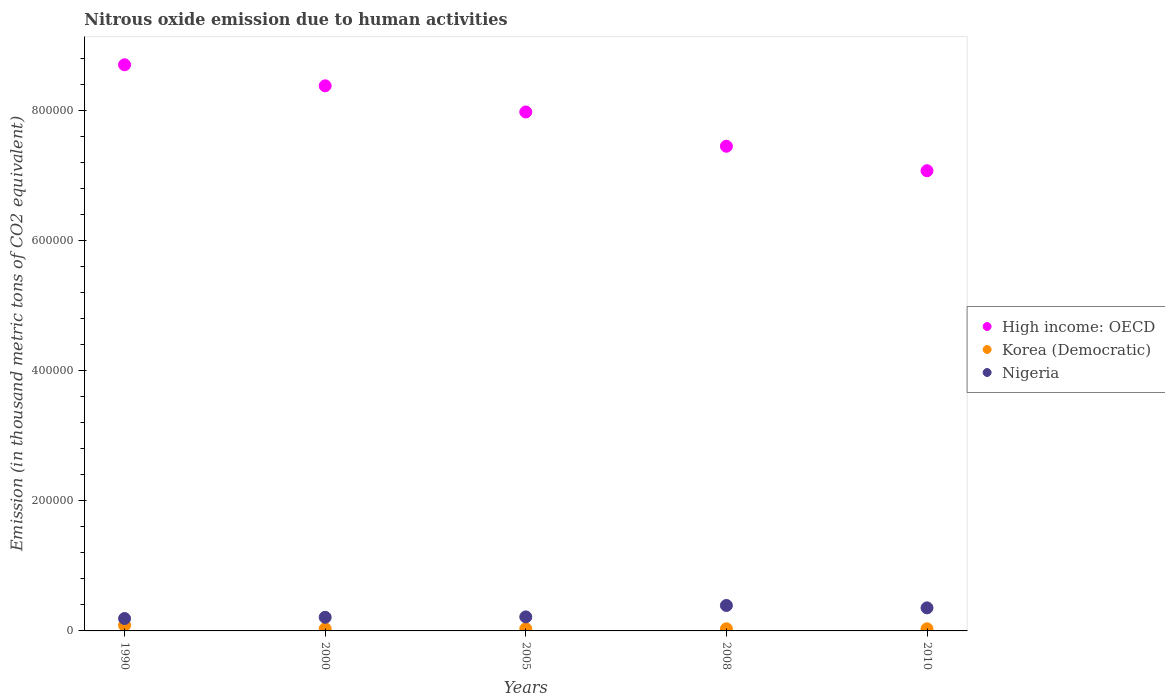Is the number of dotlines equal to the number of legend labels?
Make the answer very short. Yes. What is the amount of nitrous oxide emitted in Korea (Democratic) in 2000?
Provide a succinct answer. 3310.1. Across all years, what is the maximum amount of nitrous oxide emitted in High income: OECD?
Offer a very short reply. 8.71e+05. Across all years, what is the minimum amount of nitrous oxide emitted in Nigeria?
Offer a terse response. 1.90e+04. In which year was the amount of nitrous oxide emitted in Korea (Democratic) maximum?
Keep it short and to the point. 1990. In which year was the amount of nitrous oxide emitted in Korea (Democratic) minimum?
Provide a succinct answer. 2010. What is the total amount of nitrous oxide emitted in Nigeria in the graph?
Offer a very short reply. 1.36e+05. What is the difference between the amount of nitrous oxide emitted in Korea (Democratic) in 2008 and that in 2010?
Provide a succinct answer. 35.7. What is the difference between the amount of nitrous oxide emitted in Korea (Democratic) in 2005 and the amount of nitrous oxide emitted in High income: OECD in 2010?
Provide a short and direct response. -7.05e+05. What is the average amount of nitrous oxide emitted in Korea (Democratic) per year?
Your response must be concise. 4381.74. In the year 2000, what is the difference between the amount of nitrous oxide emitted in Korea (Democratic) and amount of nitrous oxide emitted in Nigeria?
Give a very brief answer. -1.77e+04. In how many years, is the amount of nitrous oxide emitted in Korea (Democratic) greater than 680000 thousand metric tons?
Your response must be concise. 0. What is the ratio of the amount of nitrous oxide emitted in High income: OECD in 2000 to that in 2005?
Your answer should be very brief. 1.05. Is the amount of nitrous oxide emitted in Korea (Democratic) in 2000 less than that in 2008?
Your answer should be very brief. No. What is the difference between the highest and the second highest amount of nitrous oxide emitted in Nigeria?
Give a very brief answer. 3687.6. What is the difference between the highest and the lowest amount of nitrous oxide emitted in High income: OECD?
Give a very brief answer. 1.63e+05. In how many years, is the amount of nitrous oxide emitted in Nigeria greater than the average amount of nitrous oxide emitted in Nigeria taken over all years?
Make the answer very short. 2. Is the amount of nitrous oxide emitted in Korea (Democratic) strictly greater than the amount of nitrous oxide emitted in Nigeria over the years?
Your answer should be compact. No. How many years are there in the graph?
Your answer should be compact. 5. What is the difference between two consecutive major ticks on the Y-axis?
Keep it short and to the point. 2.00e+05. Are the values on the major ticks of Y-axis written in scientific E-notation?
Offer a very short reply. No. Where does the legend appear in the graph?
Ensure brevity in your answer.  Center right. How many legend labels are there?
Offer a very short reply. 3. How are the legend labels stacked?
Provide a short and direct response. Vertical. What is the title of the graph?
Make the answer very short. Nitrous oxide emission due to human activities. What is the label or title of the Y-axis?
Your response must be concise. Emission (in thousand metric tons of CO2 equivalent). What is the Emission (in thousand metric tons of CO2 equivalent) in High income: OECD in 1990?
Provide a short and direct response. 8.71e+05. What is the Emission (in thousand metric tons of CO2 equivalent) of Korea (Democratic) in 1990?
Offer a very short reply. 8714.8. What is the Emission (in thousand metric tons of CO2 equivalent) in Nigeria in 1990?
Provide a succinct answer. 1.90e+04. What is the Emission (in thousand metric tons of CO2 equivalent) in High income: OECD in 2000?
Your response must be concise. 8.39e+05. What is the Emission (in thousand metric tons of CO2 equivalent) of Korea (Democratic) in 2000?
Offer a terse response. 3310.1. What is the Emission (in thousand metric tons of CO2 equivalent) of Nigeria in 2000?
Give a very brief answer. 2.10e+04. What is the Emission (in thousand metric tons of CO2 equivalent) in High income: OECD in 2005?
Offer a very short reply. 7.98e+05. What is the Emission (in thousand metric tons of CO2 equivalent) of Korea (Democratic) in 2005?
Give a very brief answer. 3365.7. What is the Emission (in thousand metric tons of CO2 equivalent) of Nigeria in 2005?
Make the answer very short. 2.16e+04. What is the Emission (in thousand metric tons of CO2 equivalent) of High income: OECD in 2008?
Keep it short and to the point. 7.46e+05. What is the Emission (in thousand metric tons of CO2 equivalent) in Korea (Democratic) in 2008?
Keep it short and to the point. 3276.9. What is the Emission (in thousand metric tons of CO2 equivalent) of Nigeria in 2008?
Provide a succinct answer. 3.92e+04. What is the Emission (in thousand metric tons of CO2 equivalent) of High income: OECD in 2010?
Ensure brevity in your answer.  7.08e+05. What is the Emission (in thousand metric tons of CO2 equivalent) in Korea (Democratic) in 2010?
Your answer should be compact. 3241.2. What is the Emission (in thousand metric tons of CO2 equivalent) in Nigeria in 2010?
Offer a terse response. 3.55e+04. Across all years, what is the maximum Emission (in thousand metric tons of CO2 equivalent) in High income: OECD?
Your answer should be very brief. 8.71e+05. Across all years, what is the maximum Emission (in thousand metric tons of CO2 equivalent) of Korea (Democratic)?
Provide a succinct answer. 8714.8. Across all years, what is the maximum Emission (in thousand metric tons of CO2 equivalent) in Nigeria?
Your answer should be very brief. 3.92e+04. Across all years, what is the minimum Emission (in thousand metric tons of CO2 equivalent) of High income: OECD?
Keep it short and to the point. 7.08e+05. Across all years, what is the minimum Emission (in thousand metric tons of CO2 equivalent) in Korea (Democratic)?
Give a very brief answer. 3241.2. Across all years, what is the minimum Emission (in thousand metric tons of CO2 equivalent) in Nigeria?
Make the answer very short. 1.90e+04. What is the total Emission (in thousand metric tons of CO2 equivalent) of High income: OECD in the graph?
Provide a short and direct response. 3.96e+06. What is the total Emission (in thousand metric tons of CO2 equivalent) in Korea (Democratic) in the graph?
Make the answer very short. 2.19e+04. What is the total Emission (in thousand metric tons of CO2 equivalent) of Nigeria in the graph?
Give a very brief answer. 1.36e+05. What is the difference between the Emission (in thousand metric tons of CO2 equivalent) of High income: OECD in 1990 and that in 2000?
Your answer should be compact. 3.24e+04. What is the difference between the Emission (in thousand metric tons of CO2 equivalent) in Korea (Democratic) in 1990 and that in 2000?
Offer a very short reply. 5404.7. What is the difference between the Emission (in thousand metric tons of CO2 equivalent) of Nigeria in 1990 and that in 2000?
Provide a succinct answer. -1924. What is the difference between the Emission (in thousand metric tons of CO2 equivalent) of High income: OECD in 1990 and that in 2005?
Offer a terse response. 7.26e+04. What is the difference between the Emission (in thousand metric tons of CO2 equivalent) of Korea (Democratic) in 1990 and that in 2005?
Ensure brevity in your answer.  5349.1. What is the difference between the Emission (in thousand metric tons of CO2 equivalent) in Nigeria in 1990 and that in 2005?
Keep it short and to the point. -2524.4. What is the difference between the Emission (in thousand metric tons of CO2 equivalent) of High income: OECD in 1990 and that in 2008?
Your answer should be compact. 1.25e+05. What is the difference between the Emission (in thousand metric tons of CO2 equivalent) in Korea (Democratic) in 1990 and that in 2008?
Your answer should be very brief. 5437.9. What is the difference between the Emission (in thousand metric tons of CO2 equivalent) in Nigeria in 1990 and that in 2008?
Offer a very short reply. -2.01e+04. What is the difference between the Emission (in thousand metric tons of CO2 equivalent) of High income: OECD in 1990 and that in 2010?
Your answer should be very brief. 1.63e+05. What is the difference between the Emission (in thousand metric tons of CO2 equivalent) in Korea (Democratic) in 1990 and that in 2010?
Your answer should be very brief. 5473.6. What is the difference between the Emission (in thousand metric tons of CO2 equivalent) in Nigeria in 1990 and that in 2010?
Offer a terse response. -1.64e+04. What is the difference between the Emission (in thousand metric tons of CO2 equivalent) of High income: OECD in 2000 and that in 2005?
Your answer should be very brief. 4.02e+04. What is the difference between the Emission (in thousand metric tons of CO2 equivalent) of Korea (Democratic) in 2000 and that in 2005?
Provide a succinct answer. -55.6. What is the difference between the Emission (in thousand metric tons of CO2 equivalent) in Nigeria in 2000 and that in 2005?
Provide a short and direct response. -600.4. What is the difference between the Emission (in thousand metric tons of CO2 equivalent) of High income: OECD in 2000 and that in 2008?
Make the answer very short. 9.30e+04. What is the difference between the Emission (in thousand metric tons of CO2 equivalent) of Korea (Democratic) in 2000 and that in 2008?
Offer a terse response. 33.2. What is the difference between the Emission (in thousand metric tons of CO2 equivalent) of Nigeria in 2000 and that in 2008?
Your answer should be compact. -1.82e+04. What is the difference between the Emission (in thousand metric tons of CO2 equivalent) of High income: OECD in 2000 and that in 2010?
Make the answer very short. 1.31e+05. What is the difference between the Emission (in thousand metric tons of CO2 equivalent) of Korea (Democratic) in 2000 and that in 2010?
Provide a short and direct response. 68.9. What is the difference between the Emission (in thousand metric tons of CO2 equivalent) of Nigeria in 2000 and that in 2010?
Make the answer very short. -1.45e+04. What is the difference between the Emission (in thousand metric tons of CO2 equivalent) in High income: OECD in 2005 and that in 2008?
Offer a very short reply. 5.27e+04. What is the difference between the Emission (in thousand metric tons of CO2 equivalent) of Korea (Democratic) in 2005 and that in 2008?
Offer a terse response. 88.8. What is the difference between the Emission (in thousand metric tons of CO2 equivalent) in Nigeria in 2005 and that in 2008?
Offer a terse response. -1.76e+04. What is the difference between the Emission (in thousand metric tons of CO2 equivalent) of High income: OECD in 2005 and that in 2010?
Provide a succinct answer. 9.04e+04. What is the difference between the Emission (in thousand metric tons of CO2 equivalent) in Korea (Democratic) in 2005 and that in 2010?
Provide a succinct answer. 124.5. What is the difference between the Emission (in thousand metric tons of CO2 equivalent) in Nigeria in 2005 and that in 2010?
Keep it short and to the point. -1.39e+04. What is the difference between the Emission (in thousand metric tons of CO2 equivalent) in High income: OECD in 2008 and that in 2010?
Keep it short and to the point. 3.77e+04. What is the difference between the Emission (in thousand metric tons of CO2 equivalent) in Korea (Democratic) in 2008 and that in 2010?
Ensure brevity in your answer.  35.7. What is the difference between the Emission (in thousand metric tons of CO2 equivalent) of Nigeria in 2008 and that in 2010?
Offer a very short reply. 3687.6. What is the difference between the Emission (in thousand metric tons of CO2 equivalent) of High income: OECD in 1990 and the Emission (in thousand metric tons of CO2 equivalent) of Korea (Democratic) in 2000?
Ensure brevity in your answer.  8.68e+05. What is the difference between the Emission (in thousand metric tons of CO2 equivalent) in High income: OECD in 1990 and the Emission (in thousand metric tons of CO2 equivalent) in Nigeria in 2000?
Your answer should be compact. 8.50e+05. What is the difference between the Emission (in thousand metric tons of CO2 equivalent) in Korea (Democratic) in 1990 and the Emission (in thousand metric tons of CO2 equivalent) in Nigeria in 2000?
Ensure brevity in your answer.  -1.23e+04. What is the difference between the Emission (in thousand metric tons of CO2 equivalent) in High income: OECD in 1990 and the Emission (in thousand metric tons of CO2 equivalent) in Korea (Democratic) in 2005?
Your response must be concise. 8.68e+05. What is the difference between the Emission (in thousand metric tons of CO2 equivalent) in High income: OECD in 1990 and the Emission (in thousand metric tons of CO2 equivalent) in Nigeria in 2005?
Ensure brevity in your answer.  8.49e+05. What is the difference between the Emission (in thousand metric tons of CO2 equivalent) in Korea (Democratic) in 1990 and the Emission (in thousand metric tons of CO2 equivalent) in Nigeria in 2005?
Make the answer very short. -1.29e+04. What is the difference between the Emission (in thousand metric tons of CO2 equivalent) in High income: OECD in 1990 and the Emission (in thousand metric tons of CO2 equivalent) in Korea (Democratic) in 2008?
Give a very brief answer. 8.68e+05. What is the difference between the Emission (in thousand metric tons of CO2 equivalent) of High income: OECD in 1990 and the Emission (in thousand metric tons of CO2 equivalent) of Nigeria in 2008?
Provide a short and direct response. 8.32e+05. What is the difference between the Emission (in thousand metric tons of CO2 equivalent) of Korea (Democratic) in 1990 and the Emission (in thousand metric tons of CO2 equivalent) of Nigeria in 2008?
Make the answer very short. -3.04e+04. What is the difference between the Emission (in thousand metric tons of CO2 equivalent) of High income: OECD in 1990 and the Emission (in thousand metric tons of CO2 equivalent) of Korea (Democratic) in 2010?
Your answer should be very brief. 8.68e+05. What is the difference between the Emission (in thousand metric tons of CO2 equivalent) of High income: OECD in 1990 and the Emission (in thousand metric tons of CO2 equivalent) of Nigeria in 2010?
Your answer should be very brief. 8.36e+05. What is the difference between the Emission (in thousand metric tons of CO2 equivalent) in Korea (Democratic) in 1990 and the Emission (in thousand metric tons of CO2 equivalent) in Nigeria in 2010?
Ensure brevity in your answer.  -2.68e+04. What is the difference between the Emission (in thousand metric tons of CO2 equivalent) of High income: OECD in 2000 and the Emission (in thousand metric tons of CO2 equivalent) of Korea (Democratic) in 2005?
Provide a succinct answer. 8.35e+05. What is the difference between the Emission (in thousand metric tons of CO2 equivalent) of High income: OECD in 2000 and the Emission (in thousand metric tons of CO2 equivalent) of Nigeria in 2005?
Ensure brevity in your answer.  8.17e+05. What is the difference between the Emission (in thousand metric tons of CO2 equivalent) of Korea (Democratic) in 2000 and the Emission (in thousand metric tons of CO2 equivalent) of Nigeria in 2005?
Your answer should be very brief. -1.83e+04. What is the difference between the Emission (in thousand metric tons of CO2 equivalent) in High income: OECD in 2000 and the Emission (in thousand metric tons of CO2 equivalent) in Korea (Democratic) in 2008?
Offer a very short reply. 8.35e+05. What is the difference between the Emission (in thousand metric tons of CO2 equivalent) of High income: OECD in 2000 and the Emission (in thousand metric tons of CO2 equivalent) of Nigeria in 2008?
Your answer should be very brief. 7.99e+05. What is the difference between the Emission (in thousand metric tons of CO2 equivalent) of Korea (Democratic) in 2000 and the Emission (in thousand metric tons of CO2 equivalent) of Nigeria in 2008?
Your response must be concise. -3.59e+04. What is the difference between the Emission (in thousand metric tons of CO2 equivalent) of High income: OECD in 2000 and the Emission (in thousand metric tons of CO2 equivalent) of Korea (Democratic) in 2010?
Keep it short and to the point. 8.35e+05. What is the difference between the Emission (in thousand metric tons of CO2 equivalent) in High income: OECD in 2000 and the Emission (in thousand metric tons of CO2 equivalent) in Nigeria in 2010?
Offer a terse response. 8.03e+05. What is the difference between the Emission (in thousand metric tons of CO2 equivalent) in Korea (Democratic) in 2000 and the Emission (in thousand metric tons of CO2 equivalent) in Nigeria in 2010?
Provide a short and direct response. -3.22e+04. What is the difference between the Emission (in thousand metric tons of CO2 equivalent) in High income: OECD in 2005 and the Emission (in thousand metric tons of CO2 equivalent) in Korea (Democratic) in 2008?
Keep it short and to the point. 7.95e+05. What is the difference between the Emission (in thousand metric tons of CO2 equivalent) of High income: OECD in 2005 and the Emission (in thousand metric tons of CO2 equivalent) of Nigeria in 2008?
Make the answer very short. 7.59e+05. What is the difference between the Emission (in thousand metric tons of CO2 equivalent) in Korea (Democratic) in 2005 and the Emission (in thousand metric tons of CO2 equivalent) in Nigeria in 2008?
Give a very brief answer. -3.58e+04. What is the difference between the Emission (in thousand metric tons of CO2 equivalent) in High income: OECD in 2005 and the Emission (in thousand metric tons of CO2 equivalent) in Korea (Democratic) in 2010?
Make the answer very short. 7.95e+05. What is the difference between the Emission (in thousand metric tons of CO2 equivalent) in High income: OECD in 2005 and the Emission (in thousand metric tons of CO2 equivalent) in Nigeria in 2010?
Make the answer very short. 7.63e+05. What is the difference between the Emission (in thousand metric tons of CO2 equivalent) of Korea (Democratic) in 2005 and the Emission (in thousand metric tons of CO2 equivalent) of Nigeria in 2010?
Your answer should be very brief. -3.21e+04. What is the difference between the Emission (in thousand metric tons of CO2 equivalent) of High income: OECD in 2008 and the Emission (in thousand metric tons of CO2 equivalent) of Korea (Democratic) in 2010?
Your response must be concise. 7.42e+05. What is the difference between the Emission (in thousand metric tons of CO2 equivalent) of High income: OECD in 2008 and the Emission (in thousand metric tons of CO2 equivalent) of Nigeria in 2010?
Ensure brevity in your answer.  7.10e+05. What is the difference between the Emission (in thousand metric tons of CO2 equivalent) in Korea (Democratic) in 2008 and the Emission (in thousand metric tons of CO2 equivalent) in Nigeria in 2010?
Your response must be concise. -3.22e+04. What is the average Emission (in thousand metric tons of CO2 equivalent) of High income: OECD per year?
Provide a succinct answer. 7.92e+05. What is the average Emission (in thousand metric tons of CO2 equivalent) of Korea (Democratic) per year?
Your response must be concise. 4381.74. What is the average Emission (in thousand metric tons of CO2 equivalent) of Nigeria per year?
Your response must be concise. 2.72e+04. In the year 1990, what is the difference between the Emission (in thousand metric tons of CO2 equivalent) in High income: OECD and Emission (in thousand metric tons of CO2 equivalent) in Korea (Democratic)?
Ensure brevity in your answer.  8.62e+05. In the year 1990, what is the difference between the Emission (in thousand metric tons of CO2 equivalent) in High income: OECD and Emission (in thousand metric tons of CO2 equivalent) in Nigeria?
Provide a short and direct response. 8.52e+05. In the year 1990, what is the difference between the Emission (in thousand metric tons of CO2 equivalent) of Korea (Democratic) and Emission (in thousand metric tons of CO2 equivalent) of Nigeria?
Keep it short and to the point. -1.03e+04. In the year 2000, what is the difference between the Emission (in thousand metric tons of CO2 equivalent) in High income: OECD and Emission (in thousand metric tons of CO2 equivalent) in Korea (Democratic)?
Your answer should be compact. 8.35e+05. In the year 2000, what is the difference between the Emission (in thousand metric tons of CO2 equivalent) of High income: OECD and Emission (in thousand metric tons of CO2 equivalent) of Nigeria?
Provide a short and direct response. 8.18e+05. In the year 2000, what is the difference between the Emission (in thousand metric tons of CO2 equivalent) of Korea (Democratic) and Emission (in thousand metric tons of CO2 equivalent) of Nigeria?
Make the answer very short. -1.77e+04. In the year 2005, what is the difference between the Emission (in thousand metric tons of CO2 equivalent) in High income: OECD and Emission (in thousand metric tons of CO2 equivalent) in Korea (Democratic)?
Provide a succinct answer. 7.95e+05. In the year 2005, what is the difference between the Emission (in thousand metric tons of CO2 equivalent) in High income: OECD and Emission (in thousand metric tons of CO2 equivalent) in Nigeria?
Provide a succinct answer. 7.77e+05. In the year 2005, what is the difference between the Emission (in thousand metric tons of CO2 equivalent) in Korea (Democratic) and Emission (in thousand metric tons of CO2 equivalent) in Nigeria?
Your response must be concise. -1.82e+04. In the year 2008, what is the difference between the Emission (in thousand metric tons of CO2 equivalent) of High income: OECD and Emission (in thousand metric tons of CO2 equivalent) of Korea (Democratic)?
Provide a succinct answer. 7.42e+05. In the year 2008, what is the difference between the Emission (in thousand metric tons of CO2 equivalent) in High income: OECD and Emission (in thousand metric tons of CO2 equivalent) in Nigeria?
Your answer should be very brief. 7.07e+05. In the year 2008, what is the difference between the Emission (in thousand metric tons of CO2 equivalent) in Korea (Democratic) and Emission (in thousand metric tons of CO2 equivalent) in Nigeria?
Your response must be concise. -3.59e+04. In the year 2010, what is the difference between the Emission (in thousand metric tons of CO2 equivalent) of High income: OECD and Emission (in thousand metric tons of CO2 equivalent) of Korea (Democratic)?
Ensure brevity in your answer.  7.05e+05. In the year 2010, what is the difference between the Emission (in thousand metric tons of CO2 equivalent) in High income: OECD and Emission (in thousand metric tons of CO2 equivalent) in Nigeria?
Give a very brief answer. 6.73e+05. In the year 2010, what is the difference between the Emission (in thousand metric tons of CO2 equivalent) of Korea (Democratic) and Emission (in thousand metric tons of CO2 equivalent) of Nigeria?
Provide a short and direct response. -3.22e+04. What is the ratio of the Emission (in thousand metric tons of CO2 equivalent) in High income: OECD in 1990 to that in 2000?
Your answer should be very brief. 1.04. What is the ratio of the Emission (in thousand metric tons of CO2 equivalent) in Korea (Democratic) in 1990 to that in 2000?
Offer a terse response. 2.63. What is the ratio of the Emission (in thousand metric tons of CO2 equivalent) of Nigeria in 1990 to that in 2000?
Make the answer very short. 0.91. What is the ratio of the Emission (in thousand metric tons of CO2 equivalent) of Korea (Democratic) in 1990 to that in 2005?
Keep it short and to the point. 2.59. What is the ratio of the Emission (in thousand metric tons of CO2 equivalent) of Nigeria in 1990 to that in 2005?
Offer a very short reply. 0.88. What is the ratio of the Emission (in thousand metric tons of CO2 equivalent) of High income: OECD in 1990 to that in 2008?
Provide a short and direct response. 1.17. What is the ratio of the Emission (in thousand metric tons of CO2 equivalent) of Korea (Democratic) in 1990 to that in 2008?
Make the answer very short. 2.66. What is the ratio of the Emission (in thousand metric tons of CO2 equivalent) of Nigeria in 1990 to that in 2008?
Your response must be concise. 0.49. What is the ratio of the Emission (in thousand metric tons of CO2 equivalent) of High income: OECD in 1990 to that in 2010?
Your answer should be very brief. 1.23. What is the ratio of the Emission (in thousand metric tons of CO2 equivalent) of Korea (Democratic) in 1990 to that in 2010?
Make the answer very short. 2.69. What is the ratio of the Emission (in thousand metric tons of CO2 equivalent) of Nigeria in 1990 to that in 2010?
Offer a very short reply. 0.54. What is the ratio of the Emission (in thousand metric tons of CO2 equivalent) in High income: OECD in 2000 to that in 2005?
Offer a terse response. 1.05. What is the ratio of the Emission (in thousand metric tons of CO2 equivalent) in Korea (Democratic) in 2000 to that in 2005?
Make the answer very short. 0.98. What is the ratio of the Emission (in thousand metric tons of CO2 equivalent) in Nigeria in 2000 to that in 2005?
Offer a very short reply. 0.97. What is the ratio of the Emission (in thousand metric tons of CO2 equivalent) in High income: OECD in 2000 to that in 2008?
Ensure brevity in your answer.  1.12. What is the ratio of the Emission (in thousand metric tons of CO2 equivalent) of Nigeria in 2000 to that in 2008?
Ensure brevity in your answer.  0.54. What is the ratio of the Emission (in thousand metric tons of CO2 equivalent) of High income: OECD in 2000 to that in 2010?
Offer a terse response. 1.18. What is the ratio of the Emission (in thousand metric tons of CO2 equivalent) of Korea (Democratic) in 2000 to that in 2010?
Give a very brief answer. 1.02. What is the ratio of the Emission (in thousand metric tons of CO2 equivalent) in Nigeria in 2000 to that in 2010?
Your answer should be compact. 0.59. What is the ratio of the Emission (in thousand metric tons of CO2 equivalent) of High income: OECD in 2005 to that in 2008?
Offer a terse response. 1.07. What is the ratio of the Emission (in thousand metric tons of CO2 equivalent) of Korea (Democratic) in 2005 to that in 2008?
Make the answer very short. 1.03. What is the ratio of the Emission (in thousand metric tons of CO2 equivalent) in Nigeria in 2005 to that in 2008?
Your response must be concise. 0.55. What is the ratio of the Emission (in thousand metric tons of CO2 equivalent) in High income: OECD in 2005 to that in 2010?
Provide a succinct answer. 1.13. What is the ratio of the Emission (in thousand metric tons of CO2 equivalent) of Korea (Democratic) in 2005 to that in 2010?
Provide a succinct answer. 1.04. What is the ratio of the Emission (in thousand metric tons of CO2 equivalent) of Nigeria in 2005 to that in 2010?
Ensure brevity in your answer.  0.61. What is the ratio of the Emission (in thousand metric tons of CO2 equivalent) in High income: OECD in 2008 to that in 2010?
Provide a succinct answer. 1.05. What is the ratio of the Emission (in thousand metric tons of CO2 equivalent) in Nigeria in 2008 to that in 2010?
Ensure brevity in your answer.  1.1. What is the difference between the highest and the second highest Emission (in thousand metric tons of CO2 equivalent) of High income: OECD?
Your answer should be very brief. 3.24e+04. What is the difference between the highest and the second highest Emission (in thousand metric tons of CO2 equivalent) in Korea (Democratic)?
Offer a terse response. 5349.1. What is the difference between the highest and the second highest Emission (in thousand metric tons of CO2 equivalent) of Nigeria?
Offer a very short reply. 3687.6. What is the difference between the highest and the lowest Emission (in thousand metric tons of CO2 equivalent) in High income: OECD?
Keep it short and to the point. 1.63e+05. What is the difference between the highest and the lowest Emission (in thousand metric tons of CO2 equivalent) in Korea (Democratic)?
Your answer should be compact. 5473.6. What is the difference between the highest and the lowest Emission (in thousand metric tons of CO2 equivalent) in Nigeria?
Your answer should be very brief. 2.01e+04. 